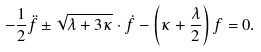<formula> <loc_0><loc_0><loc_500><loc_500>- \frac { 1 } { 2 } \ddot { f } \pm \sqrt { \lambda + 3 \kappa } \cdot \dot { f } - \left ( \kappa + \frac { \lambda } { 2 } \right ) f = 0 .</formula> 